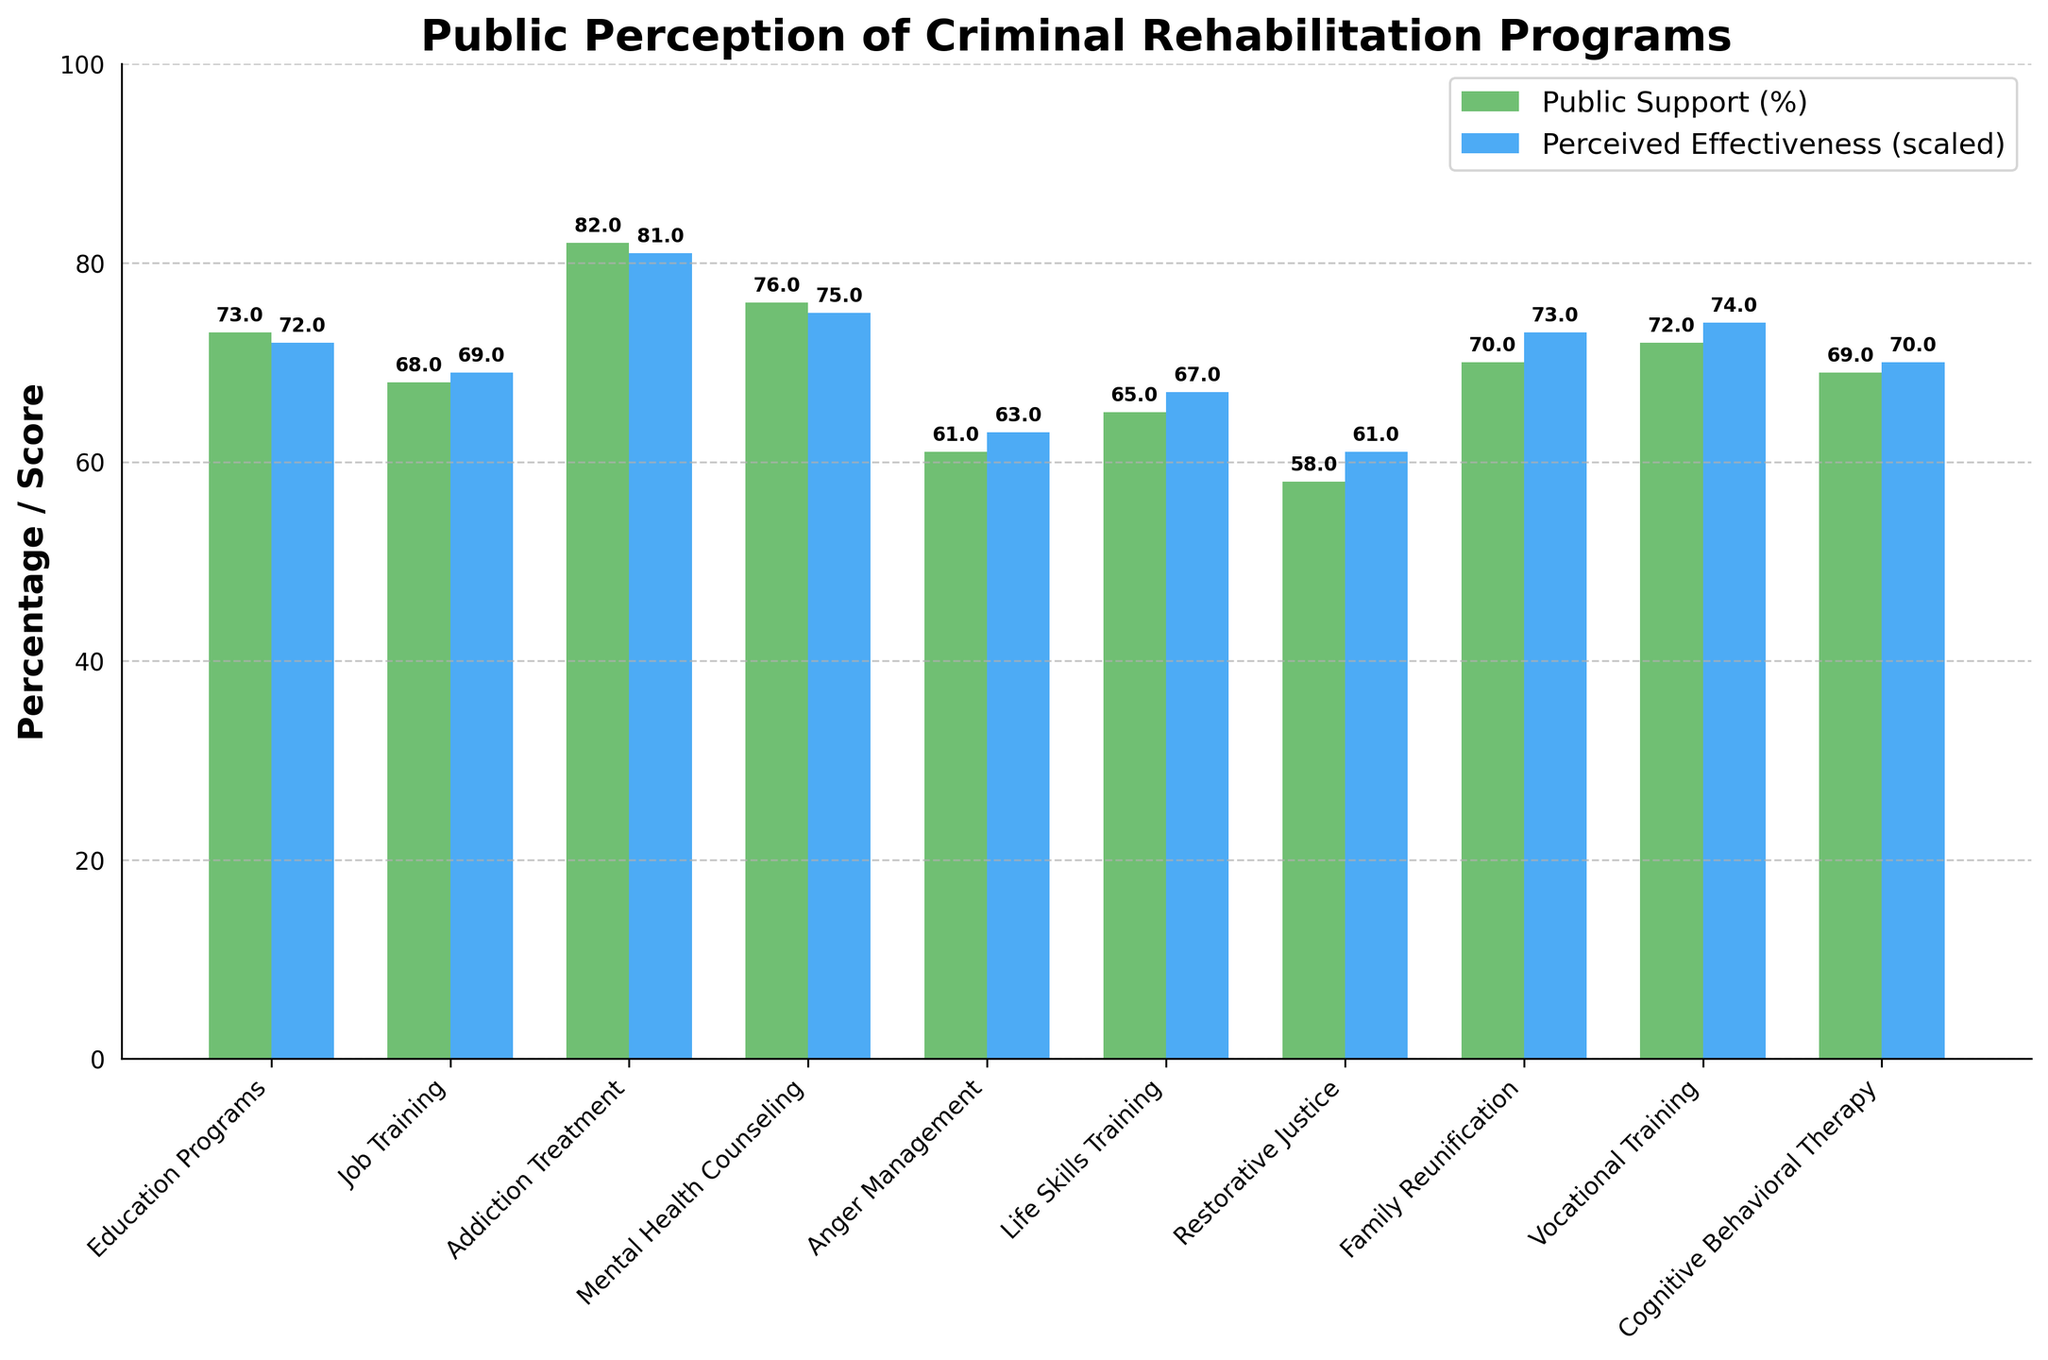What's the average public support for the programs shown? To find the average, sum up the public support percentages and divide by the number of programs. The sum is 73 + 68 + 82 + 76 + 61 + 65 + 58 + 70 + 72 + 69 = 694. Dividing this by 10 (the number of programs), we get 694 / 10 = 69.4
Answer: 69.4 Which program has the highest perceived effectiveness? By comparing the perceived effectiveness scores directly, the highest score is 8.1 for Addiction Treatment programs.
Answer: Addiction Treatment How does the public support for Addiction Treatment compare to Anger Management? The public support for Addiction Treatment is 82%, while for Anger Management, it is 61%. Therefore, public support for Addiction Treatment is higher by 21 percentage points.
Answer: Addiction Treatment is 21% higher Which program has the least public support, and what is its perceived effectiveness? Restorative Justice has the least public support at 58%. Its perceived effectiveness score is 6.1.
Answer: Restorative Justice, 6.1 What's the difference between the highest and lowest perceived effectiveness scores? The highest perceived effectiveness score is 8.1 (Addiction Treatment), and the lowest is 6.1 (Restorative Justice). The difference between these scores is 8.1 - 6.1 = 2.0.
Answer: 2.0 What is the median perceived effectiveness score of the programs? First, we list out the perceived effectiveness scores: 7.2, 6.9, 8.1, 7.5, 6.3, 6.7, 6.1, 7.3, 7.4, 7.0. We arrange them in ascending order: 6.1, 6.3, 6.7, 6.9, 7.0, 7.2, 7.3, 7.4, 7.5, 8.1. The median is the average of the 5th and 6th values, (7.0 + 7.2) / 2 = 7.1.
Answer: 7.1 What is the combined public support for Mental Health Counseling and Vocational Training? The public support for Mental Health Counseling is 76%, and for Vocational Training, it is 72%. Combined, this is 76 + 72 = 148%.
Answer: 148% 